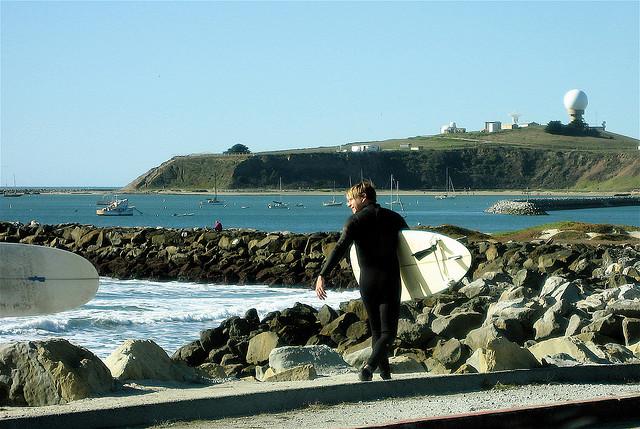What color is the suit?
Quick response, please. Black. Is he going to surf?
Keep it brief. Yes. What sport does the round white building look like?
Write a very short answer. Golf. 